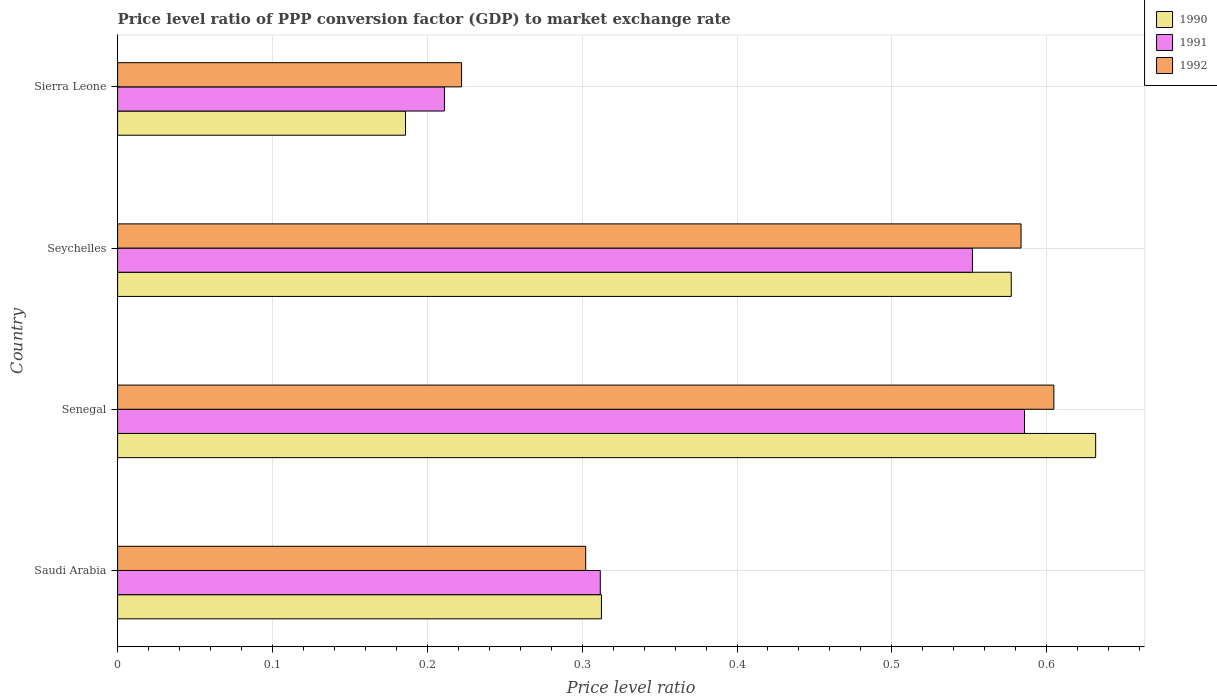Are the number of bars on each tick of the Y-axis equal?
Offer a very short reply. Yes. What is the label of the 4th group of bars from the top?
Ensure brevity in your answer.  Saudi Arabia. In how many cases, is the number of bars for a given country not equal to the number of legend labels?
Keep it short and to the point. 0. What is the price level ratio in 1990 in Saudi Arabia?
Keep it short and to the point. 0.31. Across all countries, what is the maximum price level ratio in 1990?
Offer a terse response. 0.63. Across all countries, what is the minimum price level ratio in 1992?
Give a very brief answer. 0.22. In which country was the price level ratio in 1990 maximum?
Offer a terse response. Senegal. In which country was the price level ratio in 1991 minimum?
Ensure brevity in your answer.  Sierra Leone. What is the total price level ratio in 1992 in the graph?
Make the answer very short. 1.71. What is the difference between the price level ratio in 1991 in Senegal and that in Seychelles?
Your response must be concise. 0.03. What is the difference between the price level ratio in 1991 in Saudi Arabia and the price level ratio in 1992 in Senegal?
Your answer should be very brief. -0.29. What is the average price level ratio in 1992 per country?
Make the answer very short. 0.43. What is the difference between the price level ratio in 1990 and price level ratio in 1992 in Seychelles?
Ensure brevity in your answer.  -0.01. What is the ratio of the price level ratio in 1990 in Saudi Arabia to that in Sierra Leone?
Make the answer very short. 1.68. Is the difference between the price level ratio in 1990 in Saudi Arabia and Senegal greater than the difference between the price level ratio in 1992 in Saudi Arabia and Senegal?
Ensure brevity in your answer.  No. What is the difference between the highest and the second highest price level ratio in 1991?
Keep it short and to the point. 0.03. What is the difference between the highest and the lowest price level ratio in 1990?
Keep it short and to the point. 0.45. In how many countries, is the price level ratio in 1990 greater than the average price level ratio in 1990 taken over all countries?
Ensure brevity in your answer.  2. Is the sum of the price level ratio in 1990 in Senegal and Seychelles greater than the maximum price level ratio in 1991 across all countries?
Make the answer very short. Yes. Is it the case that in every country, the sum of the price level ratio in 1992 and price level ratio in 1991 is greater than the price level ratio in 1990?
Your answer should be compact. Yes. How many bars are there?
Provide a succinct answer. 12. Are all the bars in the graph horizontal?
Provide a short and direct response. Yes. How many countries are there in the graph?
Your response must be concise. 4. Are the values on the major ticks of X-axis written in scientific E-notation?
Your response must be concise. No. How many legend labels are there?
Offer a very short reply. 3. How are the legend labels stacked?
Keep it short and to the point. Vertical. What is the title of the graph?
Provide a succinct answer. Price level ratio of PPP conversion factor (GDP) to market exchange rate. What is the label or title of the X-axis?
Offer a very short reply. Price level ratio. What is the label or title of the Y-axis?
Provide a succinct answer. Country. What is the Price level ratio of 1990 in Saudi Arabia?
Offer a very short reply. 0.31. What is the Price level ratio of 1991 in Saudi Arabia?
Keep it short and to the point. 0.31. What is the Price level ratio in 1992 in Saudi Arabia?
Your response must be concise. 0.3. What is the Price level ratio of 1990 in Senegal?
Your answer should be compact. 0.63. What is the Price level ratio in 1991 in Senegal?
Ensure brevity in your answer.  0.59. What is the Price level ratio of 1992 in Senegal?
Provide a short and direct response. 0.6. What is the Price level ratio in 1990 in Seychelles?
Provide a succinct answer. 0.58. What is the Price level ratio of 1991 in Seychelles?
Provide a short and direct response. 0.55. What is the Price level ratio in 1992 in Seychelles?
Keep it short and to the point. 0.58. What is the Price level ratio in 1990 in Sierra Leone?
Ensure brevity in your answer.  0.19. What is the Price level ratio of 1991 in Sierra Leone?
Provide a succinct answer. 0.21. What is the Price level ratio of 1992 in Sierra Leone?
Keep it short and to the point. 0.22. Across all countries, what is the maximum Price level ratio in 1990?
Keep it short and to the point. 0.63. Across all countries, what is the maximum Price level ratio of 1991?
Give a very brief answer. 0.59. Across all countries, what is the maximum Price level ratio in 1992?
Offer a very short reply. 0.6. Across all countries, what is the minimum Price level ratio in 1990?
Your answer should be very brief. 0.19. Across all countries, what is the minimum Price level ratio in 1991?
Your answer should be very brief. 0.21. Across all countries, what is the minimum Price level ratio in 1992?
Your answer should be compact. 0.22. What is the total Price level ratio in 1990 in the graph?
Your answer should be compact. 1.71. What is the total Price level ratio in 1991 in the graph?
Your answer should be very brief. 1.66. What is the total Price level ratio of 1992 in the graph?
Your answer should be very brief. 1.71. What is the difference between the Price level ratio of 1990 in Saudi Arabia and that in Senegal?
Your response must be concise. -0.32. What is the difference between the Price level ratio of 1991 in Saudi Arabia and that in Senegal?
Make the answer very short. -0.27. What is the difference between the Price level ratio of 1992 in Saudi Arabia and that in Senegal?
Offer a very short reply. -0.3. What is the difference between the Price level ratio in 1990 in Saudi Arabia and that in Seychelles?
Ensure brevity in your answer.  -0.26. What is the difference between the Price level ratio of 1991 in Saudi Arabia and that in Seychelles?
Your answer should be compact. -0.24. What is the difference between the Price level ratio in 1992 in Saudi Arabia and that in Seychelles?
Provide a succinct answer. -0.28. What is the difference between the Price level ratio in 1990 in Saudi Arabia and that in Sierra Leone?
Offer a terse response. 0.13. What is the difference between the Price level ratio in 1991 in Saudi Arabia and that in Sierra Leone?
Keep it short and to the point. 0.1. What is the difference between the Price level ratio in 1992 in Saudi Arabia and that in Sierra Leone?
Offer a very short reply. 0.08. What is the difference between the Price level ratio in 1990 in Senegal and that in Seychelles?
Provide a short and direct response. 0.05. What is the difference between the Price level ratio of 1991 in Senegal and that in Seychelles?
Provide a short and direct response. 0.03. What is the difference between the Price level ratio of 1992 in Senegal and that in Seychelles?
Keep it short and to the point. 0.02. What is the difference between the Price level ratio in 1990 in Senegal and that in Sierra Leone?
Offer a very short reply. 0.45. What is the difference between the Price level ratio of 1991 in Senegal and that in Sierra Leone?
Your answer should be compact. 0.37. What is the difference between the Price level ratio in 1992 in Senegal and that in Sierra Leone?
Provide a succinct answer. 0.38. What is the difference between the Price level ratio of 1990 in Seychelles and that in Sierra Leone?
Your response must be concise. 0.39. What is the difference between the Price level ratio in 1991 in Seychelles and that in Sierra Leone?
Keep it short and to the point. 0.34. What is the difference between the Price level ratio in 1992 in Seychelles and that in Sierra Leone?
Give a very brief answer. 0.36. What is the difference between the Price level ratio in 1990 in Saudi Arabia and the Price level ratio in 1991 in Senegal?
Ensure brevity in your answer.  -0.27. What is the difference between the Price level ratio of 1990 in Saudi Arabia and the Price level ratio of 1992 in Senegal?
Your answer should be compact. -0.29. What is the difference between the Price level ratio of 1991 in Saudi Arabia and the Price level ratio of 1992 in Senegal?
Your response must be concise. -0.29. What is the difference between the Price level ratio of 1990 in Saudi Arabia and the Price level ratio of 1991 in Seychelles?
Provide a succinct answer. -0.24. What is the difference between the Price level ratio of 1990 in Saudi Arabia and the Price level ratio of 1992 in Seychelles?
Offer a terse response. -0.27. What is the difference between the Price level ratio of 1991 in Saudi Arabia and the Price level ratio of 1992 in Seychelles?
Offer a terse response. -0.27. What is the difference between the Price level ratio of 1990 in Saudi Arabia and the Price level ratio of 1991 in Sierra Leone?
Keep it short and to the point. 0.1. What is the difference between the Price level ratio of 1990 in Saudi Arabia and the Price level ratio of 1992 in Sierra Leone?
Offer a terse response. 0.09. What is the difference between the Price level ratio of 1991 in Saudi Arabia and the Price level ratio of 1992 in Sierra Leone?
Your answer should be compact. 0.09. What is the difference between the Price level ratio of 1990 in Senegal and the Price level ratio of 1991 in Seychelles?
Offer a terse response. 0.08. What is the difference between the Price level ratio of 1990 in Senegal and the Price level ratio of 1992 in Seychelles?
Provide a succinct answer. 0.05. What is the difference between the Price level ratio of 1991 in Senegal and the Price level ratio of 1992 in Seychelles?
Provide a short and direct response. 0. What is the difference between the Price level ratio in 1990 in Senegal and the Price level ratio in 1991 in Sierra Leone?
Provide a short and direct response. 0.42. What is the difference between the Price level ratio of 1990 in Senegal and the Price level ratio of 1992 in Sierra Leone?
Make the answer very short. 0.41. What is the difference between the Price level ratio in 1991 in Senegal and the Price level ratio in 1992 in Sierra Leone?
Make the answer very short. 0.36. What is the difference between the Price level ratio in 1990 in Seychelles and the Price level ratio in 1991 in Sierra Leone?
Provide a short and direct response. 0.37. What is the difference between the Price level ratio in 1990 in Seychelles and the Price level ratio in 1992 in Sierra Leone?
Offer a terse response. 0.35. What is the difference between the Price level ratio of 1991 in Seychelles and the Price level ratio of 1992 in Sierra Leone?
Your answer should be compact. 0.33. What is the average Price level ratio of 1990 per country?
Ensure brevity in your answer.  0.43. What is the average Price level ratio in 1991 per country?
Make the answer very short. 0.42. What is the average Price level ratio of 1992 per country?
Keep it short and to the point. 0.43. What is the difference between the Price level ratio of 1990 and Price level ratio of 1991 in Saudi Arabia?
Provide a short and direct response. 0. What is the difference between the Price level ratio in 1990 and Price level ratio in 1992 in Saudi Arabia?
Give a very brief answer. 0.01. What is the difference between the Price level ratio in 1991 and Price level ratio in 1992 in Saudi Arabia?
Your response must be concise. 0.01. What is the difference between the Price level ratio in 1990 and Price level ratio in 1991 in Senegal?
Give a very brief answer. 0.05. What is the difference between the Price level ratio of 1990 and Price level ratio of 1992 in Senegal?
Offer a terse response. 0.03. What is the difference between the Price level ratio of 1991 and Price level ratio of 1992 in Senegal?
Offer a very short reply. -0.02. What is the difference between the Price level ratio of 1990 and Price level ratio of 1991 in Seychelles?
Give a very brief answer. 0.03. What is the difference between the Price level ratio in 1990 and Price level ratio in 1992 in Seychelles?
Provide a short and direct response. -0.01. What is the difference between the Price level ratio in 1991 and Price level ratio in 1992 in Seychelles?
Your answer should be very brief. -0.03. What is the difference between the Price level ratio of 1990 and Price level ratio of 1991 in Sierra Leone?
Make the answer very short. -0.03. What is the difference between the Price level ratio of 1990 and Price level ratio of 1992 in Sierra Leone?
Your answer should be very brief. -0.04. What is the difference between the Price level ratio in 1991 and Price level ratio in 1992 in Sierra Leone?
Provide a short and direct response. -0.01. What is the ratio of the Price level ratio in 1990 in Saudi Arabia to that in Senegal?
Ensure brevity in your answer.  0.49. What is the ratio of the Price level ratio in 1991 in Saudi Arabia to that in Senegal?
Make the answer very short. 0.53. What is the ratio of the Price level ratio in 1990 in Saudi Arabia to that in Seychelles?
Offer a terse response. 0.54. What is the ratio of the Price level ratio of 1991 in Saudi Arabia to that in Seychelles?
Make the answer very short. 0.56. What is the ratio of the Price level ratio of 1992 in Saudi Arabia to that in Seychelles?
Ensure brevity in your answer.  0.52. What is the ratio of the Price level ratio in 1990 in Saudi Arabia to that in Sierra Leone?
Give a very brief answer. 1.68. What is the ratio of the Price level ratio of 1991 in Saudi Arabia to that in Sierra Leone?
Your response must be concise. 1.48. What is the ratio of the Price level ratio of 1992 in Saudi Arabia to that in Sierra Leone?
Ensure brevity in your answer.  1.36. What is the ratio of the Price level ratio in 1990 in Senegal to that in Seychelles?
Your answer should be very brief. 1.09. What is the ratio of the Price level ratio of 1991 in Senegal to that in Seychelles?
Keep it short and to the point. 1.06. What is the ratio of the Price level ratio in 1992 in Senegal to that in Seychelles?
Give a very brief answer. 1.04. What is the ratio of the Price level ratio of 1990 in Senegal to that in Sierra Leone?
Keep it short and to the point. 3.4. What is the ratio of the Price level ratio of 1991 in Senegal to that in Sierra Leone?
Your answer should be very brief. 2.77. What is the ratio of the Price level ratio in 1992 in Senegal to that in Sierra Leone?
Provide a succinct answer. 2.72. What is the ratio of the Price level ratio in 1990 in Seychelles to that in Sierra Leone?
Ensure brevity in your answer.  3.1. What is the ratio of the Price level ratio in 1991 in Seychelles to that in Sierra Leone?
Your response must be concise. 2.62. What is the ratio of the Price level ratio in 1992 in Seychelles to that in Sierra Leone?
Give a very brief answer. 2.63. What is the difference between the highest and the second highest Price level ratio of 1990?
Your answer should be compact. 0.05. What is the difference between the highest and the second highest Price level ratio of 1991?
Your answer should be very brief. 0.03. What is the difference between the highest and the second highest Price level ratio of 1992?
Offer a terse response. 0.02. What is the difference between the highest and the lowest Price level ratio of 1990?
Your answer should be compact. 0.45. What is the difference between the highest and the lowest Price level ratio of 1991?
Provide a short and direct response. 0.37. What is the difference between the highest and the lowest Price level ratio in 1992?
Your answer should be compact. 0.38. 